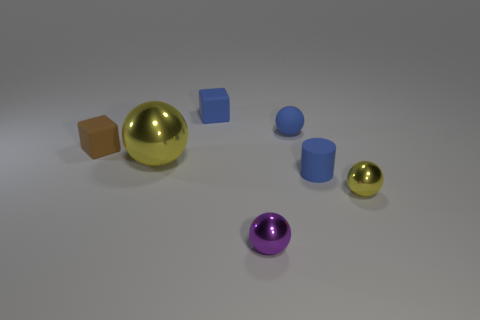Subtract all tiny matte spheres. How many spheres are left? 3 Subtract all blue spheres. How many spheres are left? 3 Add 3 purple shiny things. How many objects exist? 10 Subtract all green spheres. Subtract all blue cubes. How many spheres are left? 4 Subtract all cylinders. How many objects are left? 6 Add 2 yellow spheres. How many yellow spheres are left? 4 Add 1 small brown matte cylinders. How many small brown matte cylinders exist? 1 Subtract 2 yellow spheres. How many objects are left? 5 Subtract all tiny purple rubber objects. Subtract all matte blocks. How many objects are left? 5 